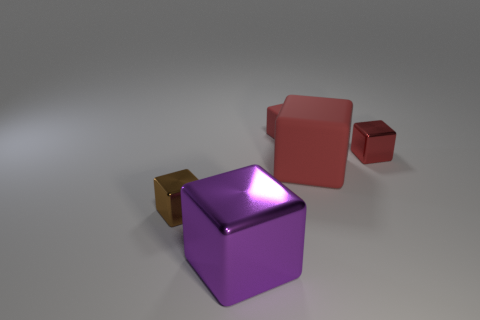How many red blocks must be subtracted to get 1 red blocks? 2 Subtract all brown balls. How many red blocks are left? 3 Subtract all purple blocks. How many blocks are left? 4 Subtract all large matte cubes. How many cubes are left? 4 Subtract all brown cubes. Subtract all cyan spheres. How many cubes are left? 4 Add 3 red things. How many objects exist? 8 Add 5 big red matte things. How many big red matte things exist? 6 Subtract 0 blue cylinders. How many objects are left? 5 Subtract all tiny brown shiny objects. Subtract all big red rubber blocks. How many objects are left? 3 Add 4 small brown metallic objects. How many small brown metallic objects are left? 5 